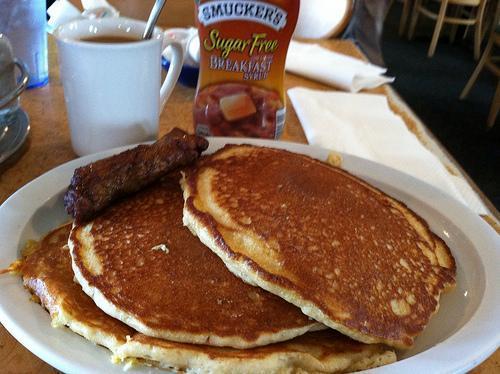How many sausage links are on the plate?
Give a very brief answer. 2. How many pancakes are there?
Give a very brief answer. 3. How many plates are there?
Give a very brief answer. 1. How many napkins are there?
Give a very brief answer. 2. How many mugs are there?
Give a very brief answer. 1. 